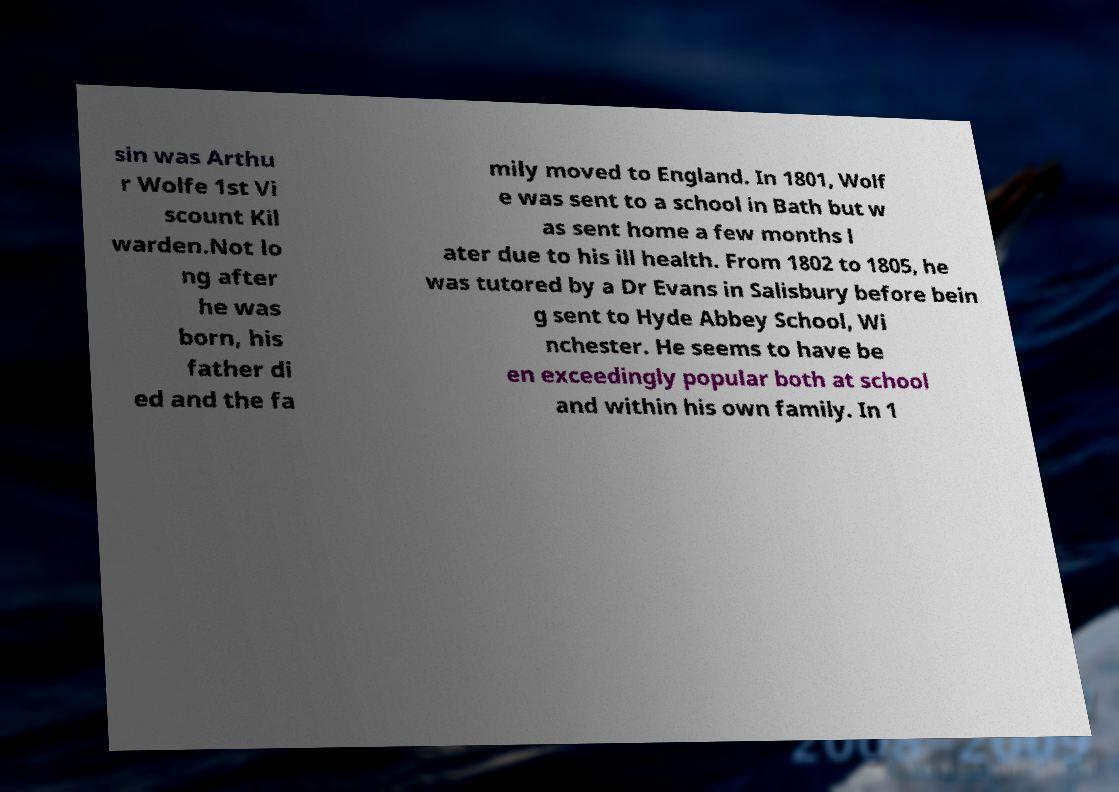Can you accurately transcribe the text from the provided image for me? sin was Arthu r Wolfe 1st Vi scount Kil warden.Not lo ng after he was born, his father di ed and the fa mily moved to England. In 1801, Wolf e was sent to a school in Bath but w as sent home a few months l ater due to his ill health. From 1802 to 1805, he was tutored by a Dr Evans in Salisbury before bein g sent to Hyde Abbey School, Wi nchester. He seems to have be en exceedingly popular both at school and within his own family. In 1 